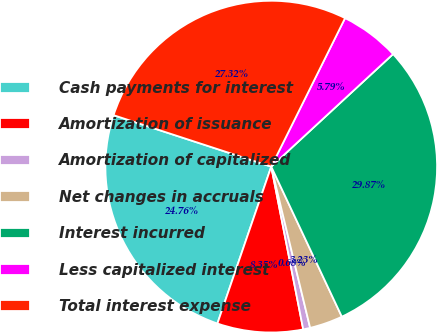<chart> <loc_0><loc_0><loc_500><loc_500><pie_chart><fcel>Cash payments for interest<fcel>Amortization of issuance<fcel>Amortization of capitalized<fcel>Net changes in accruals<fcel>Interest incurred<fcel>Less capitalized interest<fcel>Total interest expense<nl><fcel>24.76%<fcel>8.35%<fcel>0.68%<fcel>3.23%<fcel>29.87%<fcel>5.79%<fcel>27.32%<nl></chart> 